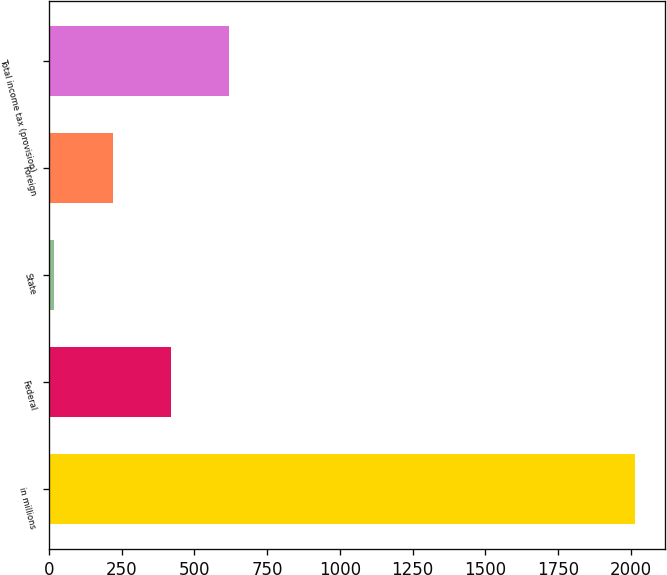Convert chart to OTSL. <chart><loc_0><loc_0><loc_500><loc_500><bar_chart><fcel>in millions<fcel>Federal<fcel>State<fcel>Foreign<fcel>Total income tax (provision)<nl><fcel>2016<fcel>418.32<fcel>18.9<fcel>218.61<fcel>618.03<nl></chart> 